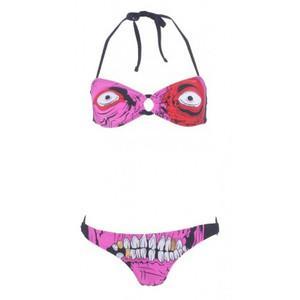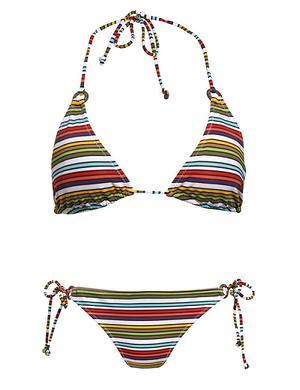The first image is the image on the left, the second image is the image on the right. For the images shown, is this caption "At least one bikini bottom ties on with strings." true? Answer yes or no. Yes. 